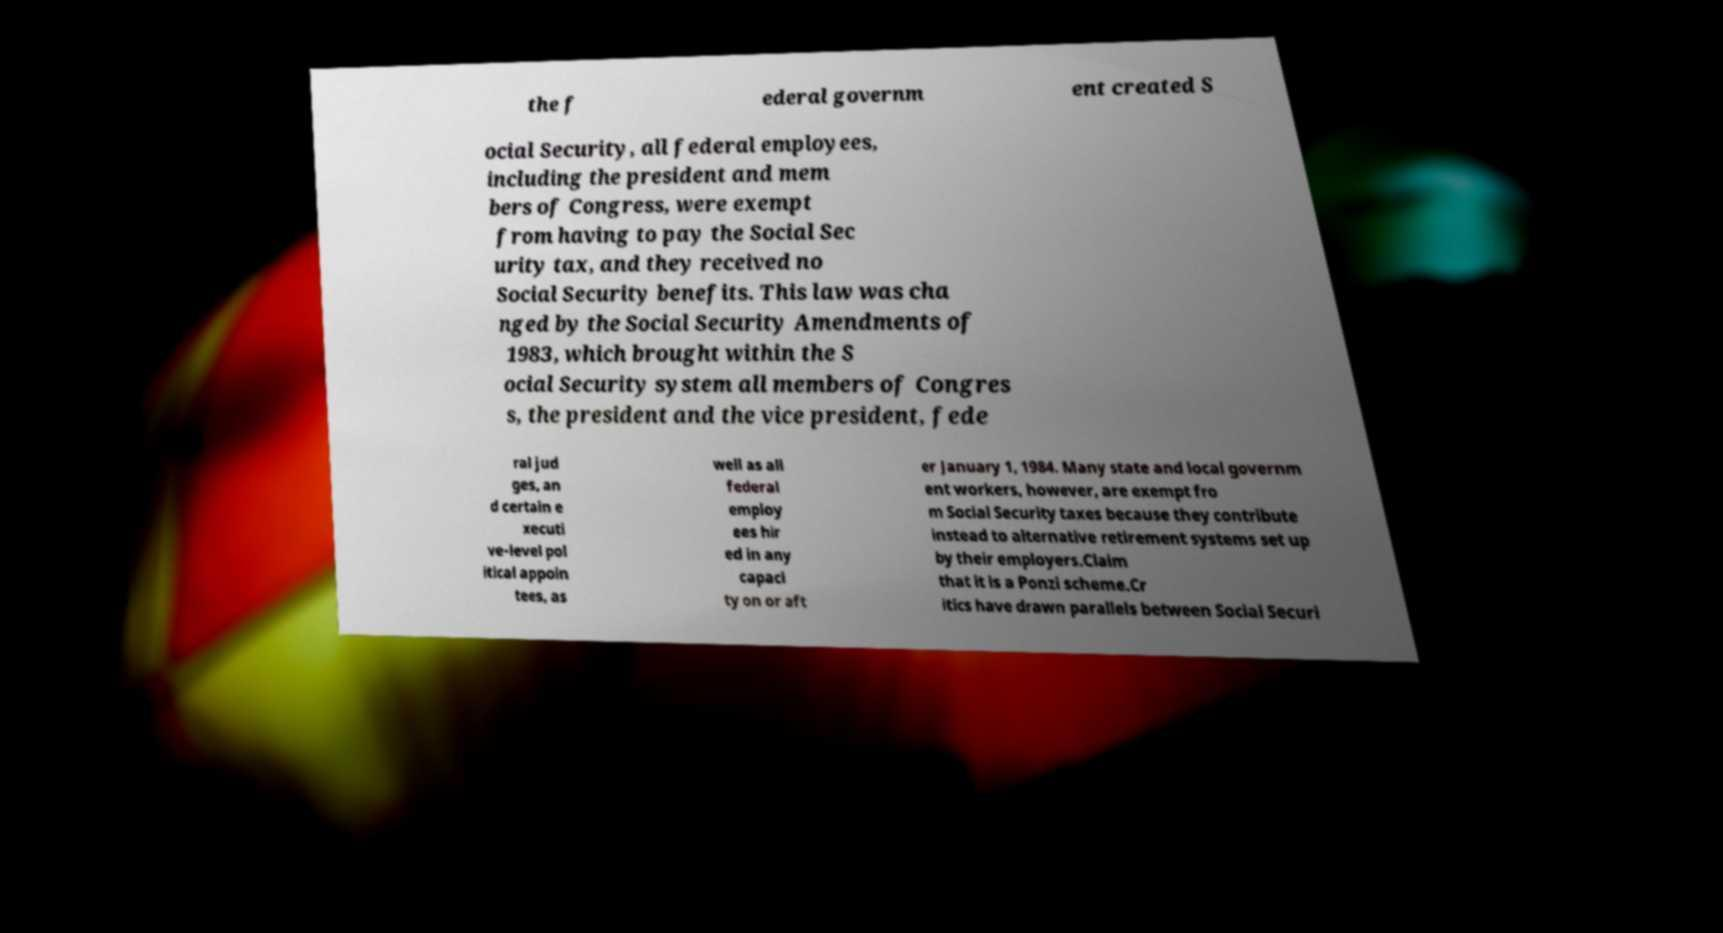Please read and relay the text visible in this image. What does it say? the f ederal governm ent created S ocial Security, all federal employees, including the president and mem bers of Congress, were exempt from having to pay the Social Sec urity tax, and they received no Social Security benefits. This law was cha nged by the Social Security Amendments of 1983, which brought within the S ocial Security system all members of Congres s, the president and the vice president, fede ral jud ges, an d certain e xecuti ve-level pol itical appoin tees, as well as all federal employ ees hir ed in any capaci ty on or aft er January 1, 1984. Many state and local governm ent workers, however, are exempt fro m Social Security taxes because they contribute instead to alternative retirement systems set up by their employers.Claim that it is a Ponzi scheme.Cr itics have drawn parallels between Social Securi 